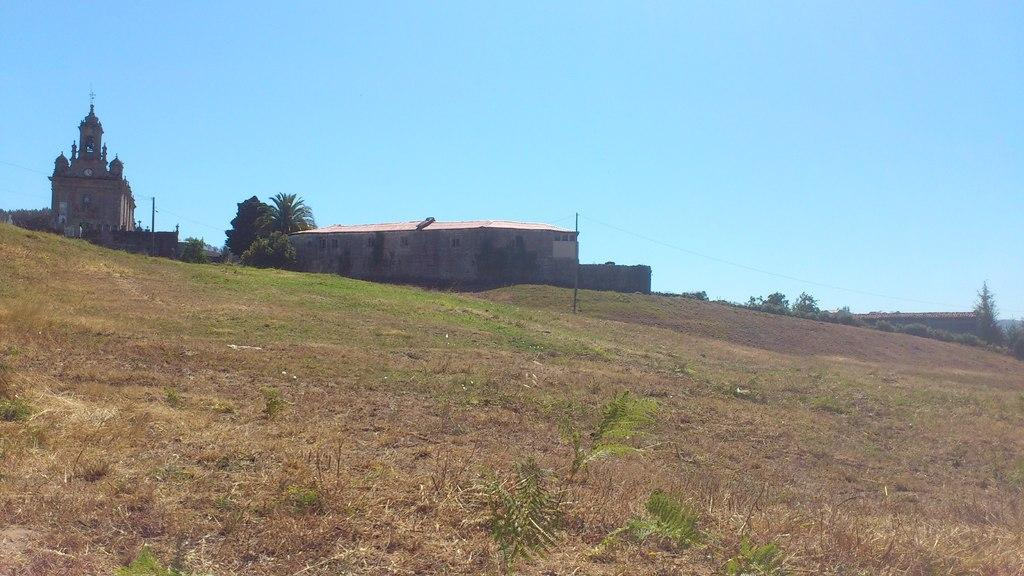What type of structures can be seen on the land in the image? There are buildings on the land in the image. What other natural elements are present in the image? There are plants, trees, and grass visible in the image. What is visible at the top of the image? The sky is visible at the top of the image. Can you tell me how many zebras are lying on the bed in the image? There are no zebras or beds present in the image. What type of soda is being served in the image? There is no soda present in the image. 